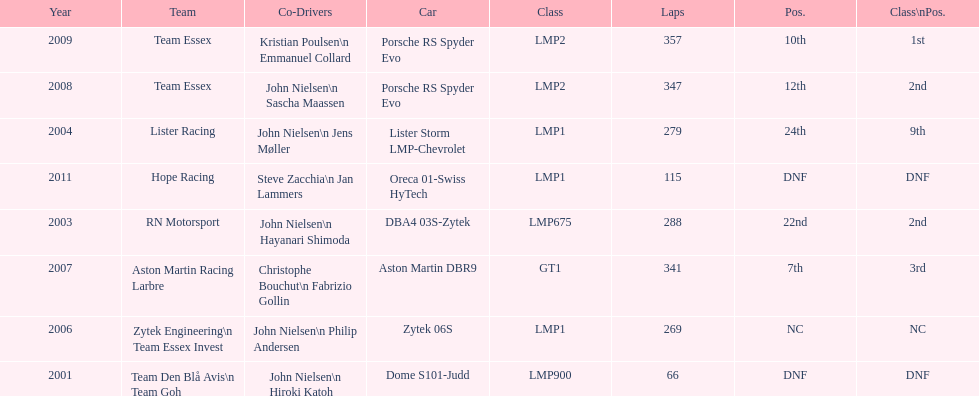Parse the full table. {'header': ['Year', 'Team', 'Co-Drivers', 'Car', 'Class', 'Laps', 'Pos.', 'Class\\nPos.'], 'rows': [['2009', 'Team Essex', 'Kristian Poulsen\\n Emmanuel Collard', 'Porsche RS Spyder Evo', 'LMP2', '357', '10th', '1st'], ['2008', 'Team Essex', 'John Nielsen\\n Sascha Maassen', 'Porsche RS Spyder Evo', 'LMP2', '347', '12th', '2nd'], ['2004', 'Lister Racing', 'John Nielsen\\n Jens Møller', 'Lister Storm LMP-Chevrolet', 'LMP1', '279', '24th', '9th'], ['2011', 'Hope Racing', 'Steve Zacchia\\n Jan Lammers', 'Oreca 01-Swiss HyTech', 'LMP1', '115', 'DNF', 'DNF'], ['2003', 'RN Motorsport', 'John Nielsen\\n Hayanari Shimoda', 'DBA4 03S-Zytek', 'LMP675', '288', '22nd', '2nd'], ['2007', 'Aston Martin Racing Larbre', 'Christophe Bouchut\\n Fabrizio Gollin', 'Aston Martin DBR9', 'GT1', '341', '7th', '3rd'], ['2006', 'Zytek Engineering\\n Team Essex Invest', 'John Nielsen\\n Philip Andersen', 'Zytek 06S', 'LMP1', '269', 'NC', 'NC'], ['2001', 'Team Den Blå Avis\\n Team Goh', 'John Nielsen\\n Hiroki Katoh', 'Dome S101-Judd', 'LMP900', '66', 'DNF', 'DNF']]} In 2008 and what other year was casper elgaard on team essex for the 24 hours of le mans? 2009. 